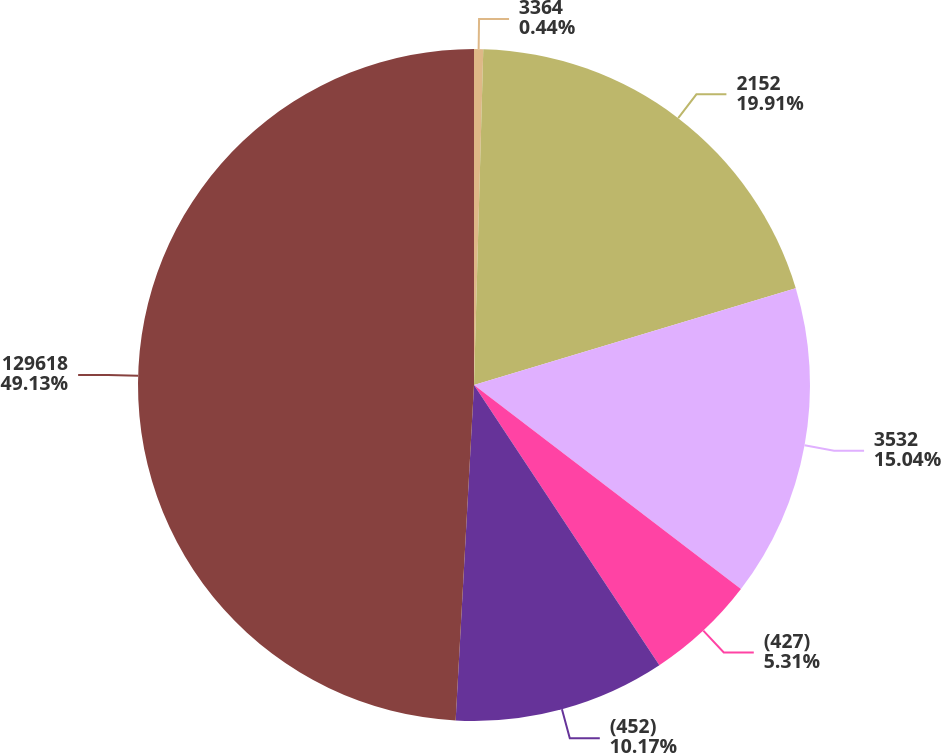Convert chart. <chart><loc_0><loc_0><loc_500><loc_500><pie_chart><fcel>3364<fcel>2152<fcel>3532<fcel>(427)<fcel>(452)<fcel>129618<nl><fcel>0.44%<fcel>19.91%<fcel>15.04%<fcel>5.31%<fcel>10.17%<fcel>49.13%<nl></chart> 